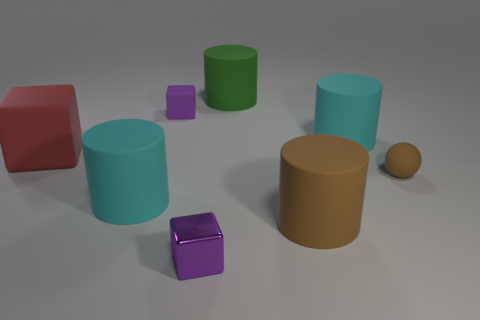Subtract 1 cylinders. How many cylinders are left? 3 Subtract all brown cylinders. How many cylinders are left? 3 Subtract all yellow cylinders. Subtract all purple balls. How many cylinders are left? 4 Add 2 small purple cubes. How many objects exist? 10 Subtract all cubes. How many objects are left? 5 Add 8 purple metal blocks. How many purple metal blocks exist? 9 Subtract 0 yellow blocks. How many objects are left? 8 Subtract all big brown things. Subtract all rubber spheres. How many objects are left? 6 Add 1 cyan matte cylinders. How many cyan matte cylinders are left? 3 